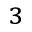Convert formula to latex. <formula><loc_0><loc_0><loc_500><loc_500>^ { 3 }</formula> 